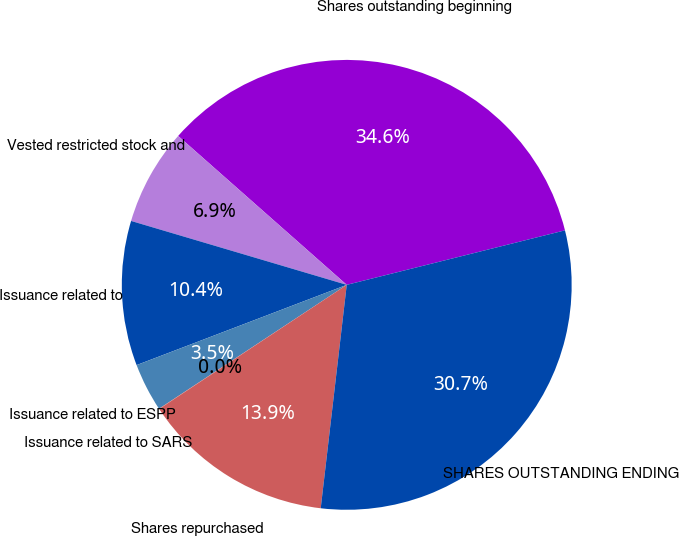Convert chart to OTSL. <chart><loc_0><loc_0><loc_500><loc_500><pie_chart><fcel>Shares outstanding beginning<fcel>Vested restricted stock and<fcel>Issuance related to<fcel>Issuance related to ESPP<fcel>Issuance related to SARS<fcel>Shares repurchased<fcel>SHARES OUTSTANDING ENDING<nl><fcel>34.59%<fcel>6.93%<fcel>10.39%<fcel>3.48%<fcel>0.02%<fcel>13.85%<fcel>30.74%<nl></chart> 